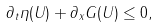<formula> <loc_0><loc_0><loc_500><loc_500>\partial _ { t } { \eta ( U ) } + \partial _ { x } { G ( U ) } \leq 0 ,</formula> 